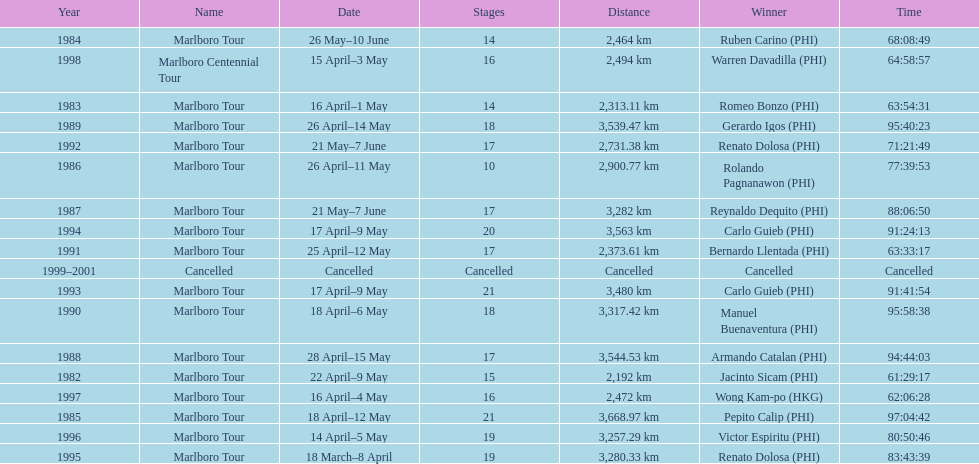What was the total number of winners before the tour was canceled? 17. 